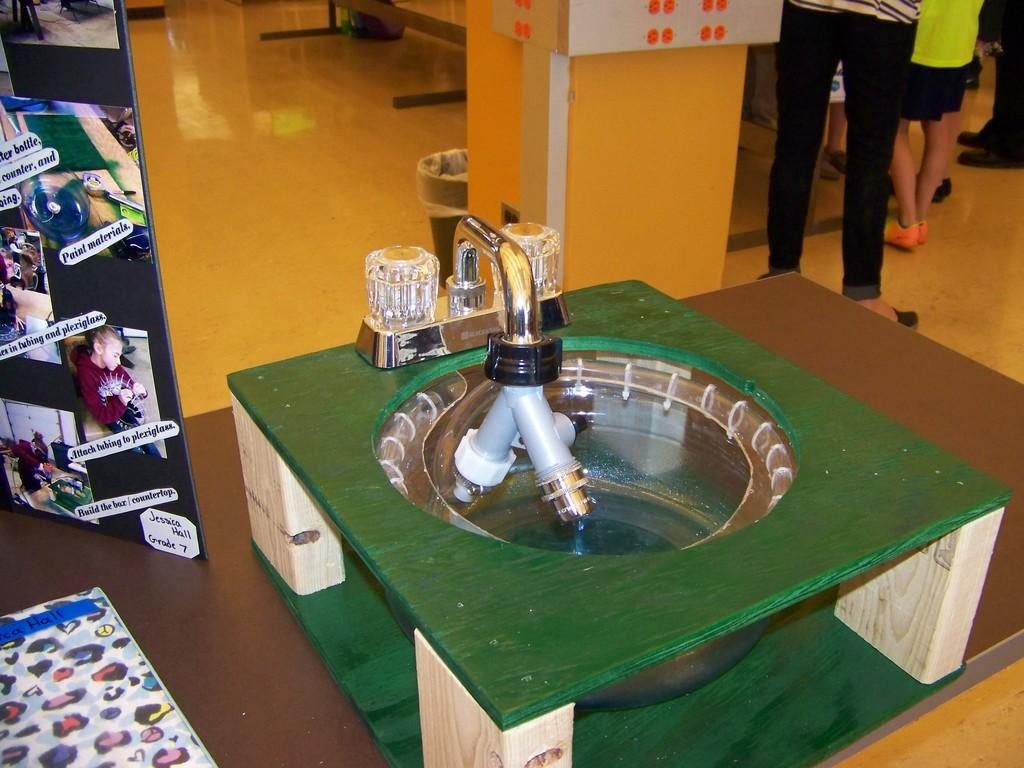What color is the table in the image? The table in the image is green. What can be found on the table? There is an object or objects on the table. Where are the photos located in the image? The photos are in the left corner of the image. What color is the background wall in the image? The background wall is yellow in color. What type of religion is being practiced in the image? There is no indication of any religious practice in the image. What cable is connected to the object on the table? There is no cable visible in the image. 